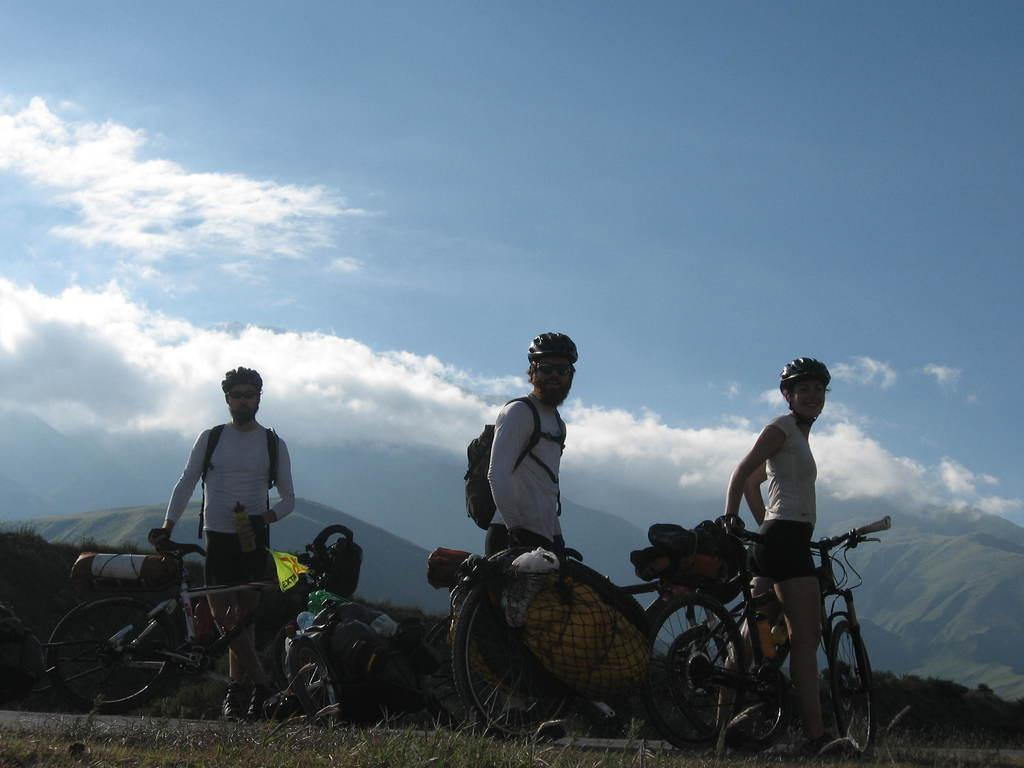What is the condition of the sky in the image? The sky is cloudy in the image. What are the persons holding in the image? They are holding a bicycle. What is one person holding in addition to the bicycle? One person is holding a bottle and a bag. How many persons are wearing helmets in the image? Three persons are wearing helmets. What can be seen in the distance in the image? There are mountains in the distance. What type of circle can be seen on the bicycle in the image? There is no circle present on the bicycle in the image. What kind of beam is supporting the persons in the image? There is no beam present in the image; the persons are standing on the ground. 